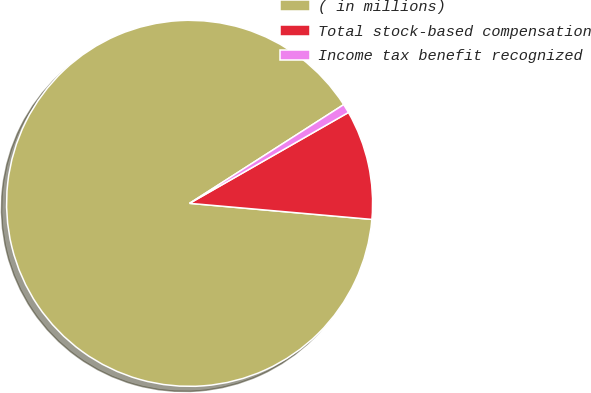Convert chart. <chart><loc_0><loc_0><loc_500><loc_500><pie_chart><fcel>( in millions)<fcel>Total stock-based compensation<fcel>Income tax benefit recognized<nl><fcel>89.53%<fcel>9.67%<fcel>0.8%<nl></chart> 